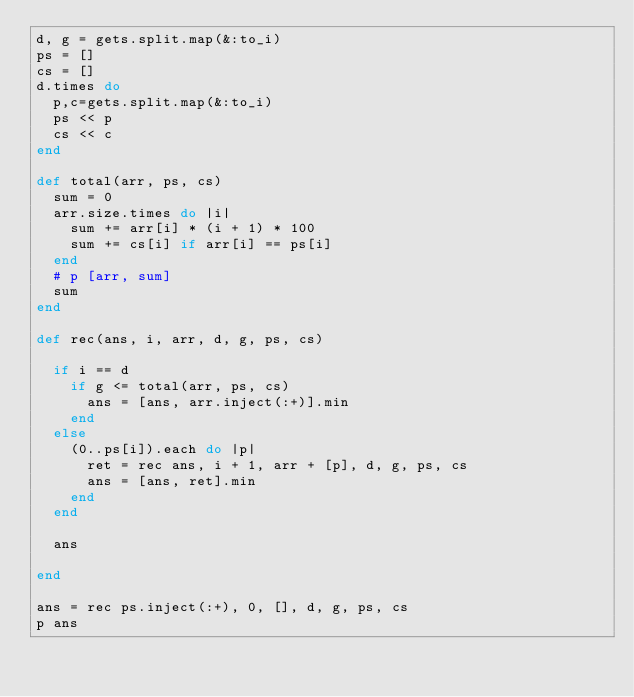Convert code to text. <code><loc_0><loc_0><loc_500><loc_500><_Ruby_>d, g = gets.split.map(&:to_i)
ps = []
cs = []
d.times do
  p,c=gets.split.map(&:to_i)
  ps << p
  cs << c
end

def total(arr, ps, cs)
  sum = 0
  arr.size.times do |i|
    sum += arr[i] * (i + 1) * 100
    sum += cs[i] if arr[i] == ps[i]
  end
  # p [arr, sum]
  sum
end

def rec(ans, i, arr, d, g, ps, cs)

  if i == d
    if g <= total(arr, ps, cs)
      ans = [ans, arr.inject(:+)].min
    end
  else
    (0..ps[i]).each do |p|
      ret = rec ans, i + 1, arr + [p], d, g, ps, cs
      ans = [ans, ret].min
    end
  end

  ans

end

ans = rec ps.inject(:+), 0, [], d, g, ps, cs
p ans
</code> 